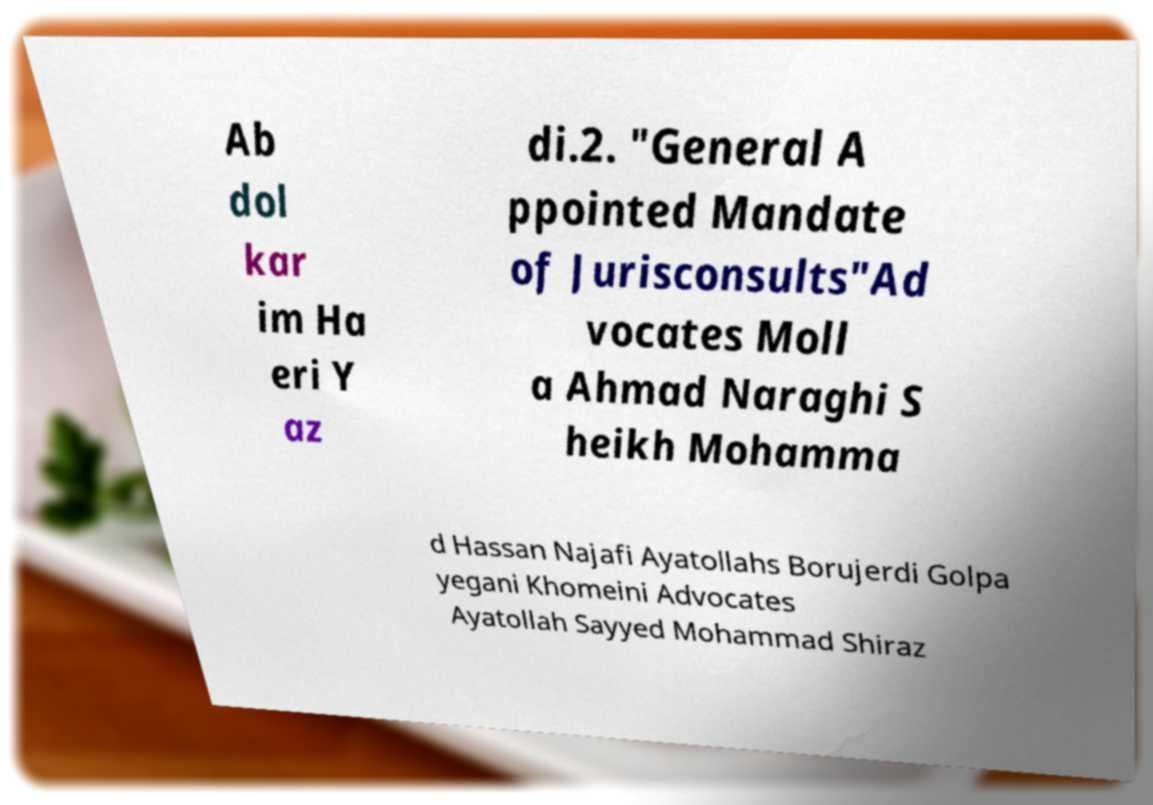Can you read and provide the text displayed in the image?This photo seems to have some interesting text. Can you extract and type it out for me? Ab dol kar im Ha eri Y az di.2. "General A ppointed Mandate of Jurisconsults"Ad vocates Moll a Ahmad Naraghi S heikh Mohamma d Hassan Najafi Ayatollahs Borujerdi Golpa yegani Khomeini Advocates Ayatollah Sayyed Mohammad Shiraz 